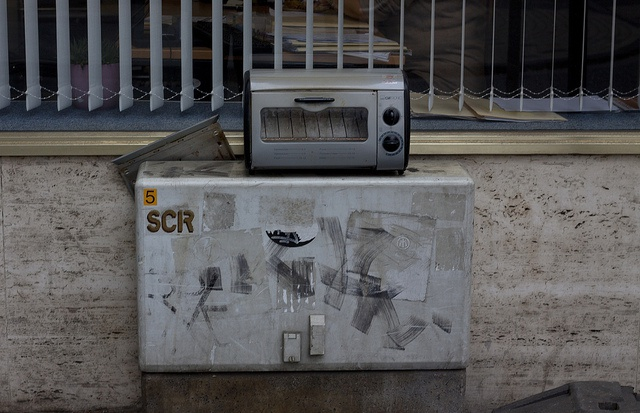Describe the objects in this image and their specific colors. I can see microwave in gray and black tones, oven in gray and black tones, book in gray and black tones, book in gray and black tones, and book in gray and black tones in this image. 